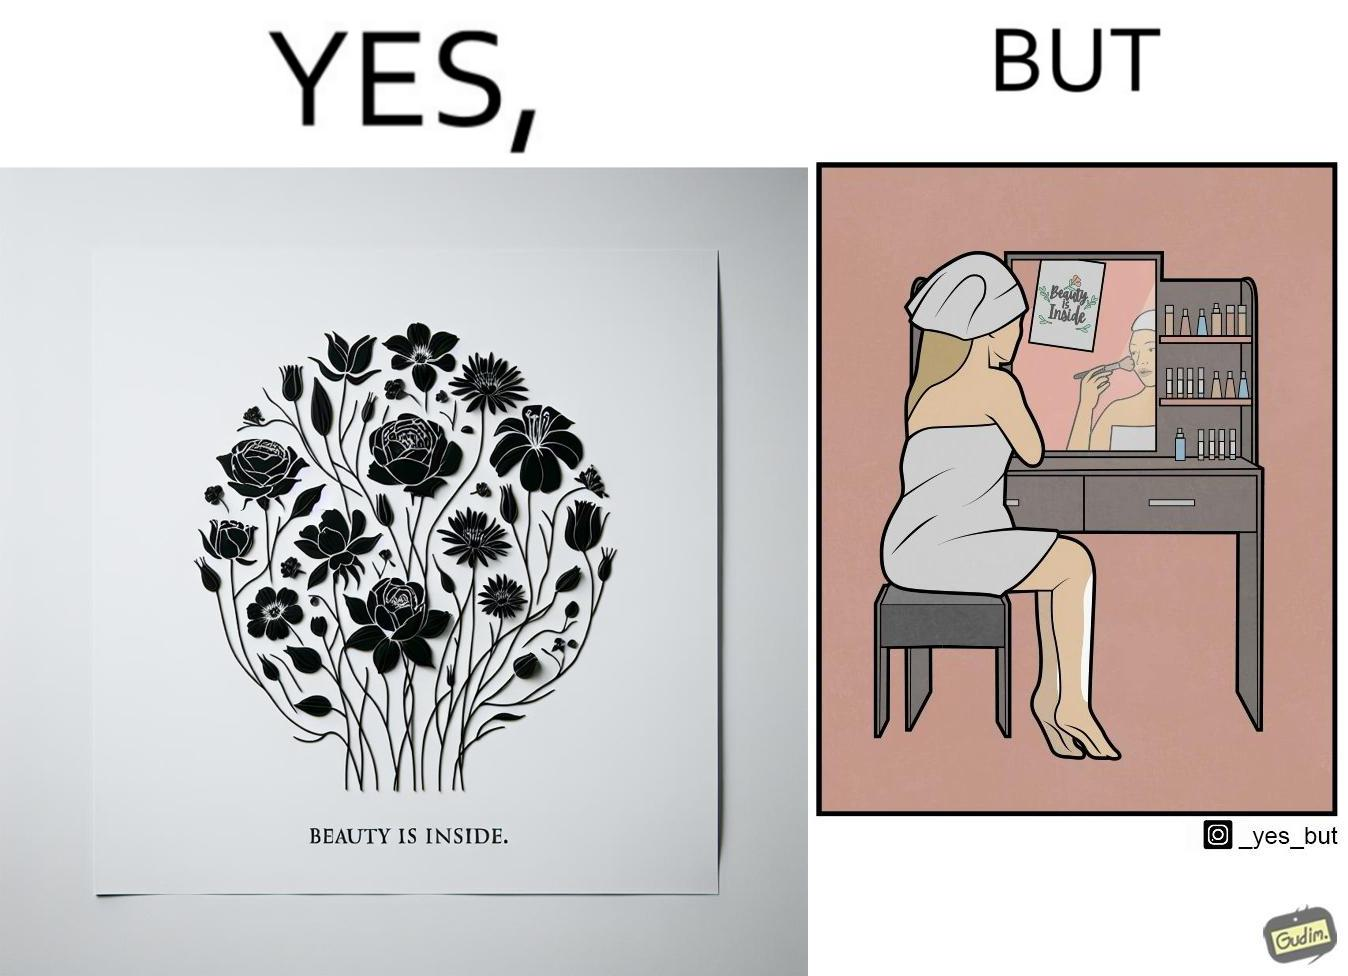Explain the humor or irony in this image. The image is satirical because while the text on the paper says that beauty lies inside, the woman ignores the note and continues to apply makeup to improve her outer beauty. 